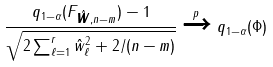<formula> <loc_0><loc_0><loc_500><loc_500>\frac { q _ { 1 - \alpha } ( F _ { \hat { \boldsymbol w } , n - m } ) - 1 } { \sqrt { 2 \sum _ { \ell = 1 } ^ { r } \hat { w } _ { \ell } ^ { 2 } + 2 / ( n - m ) } } \xrightarrow { p } q _ { 1 - \alpha } ( \Phi )</formula> 